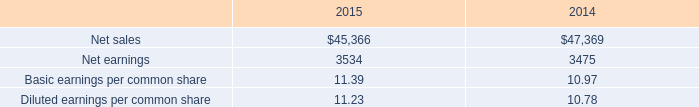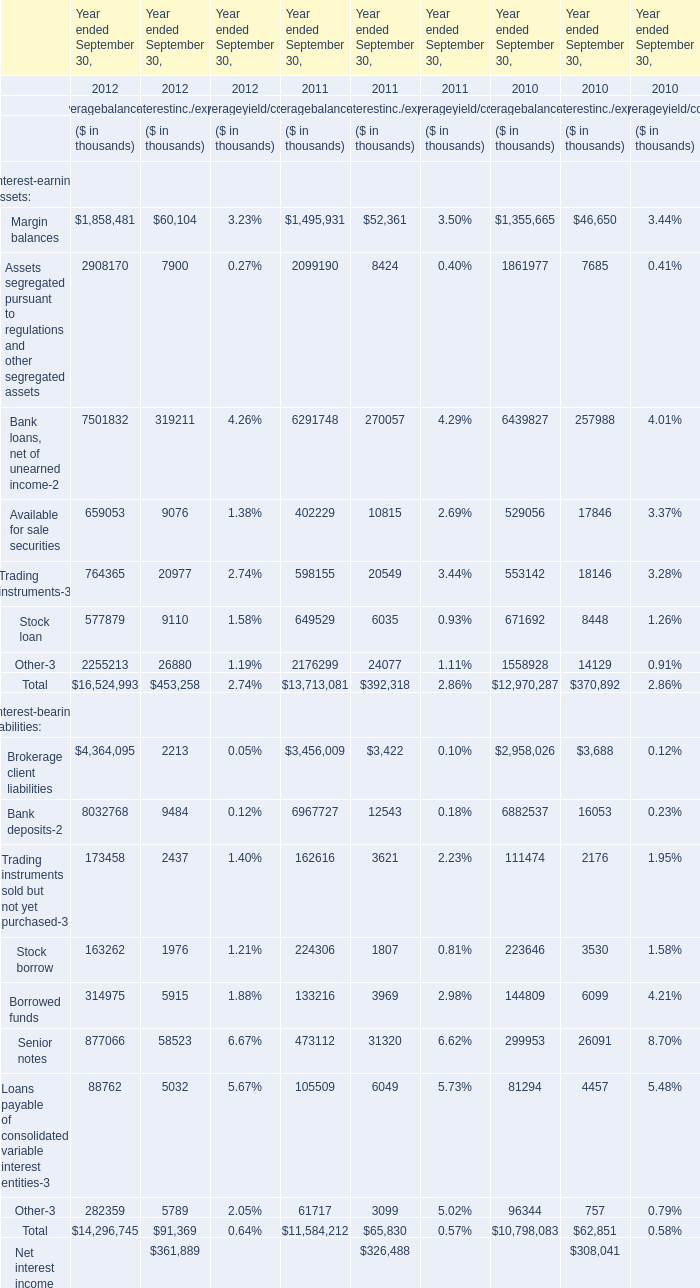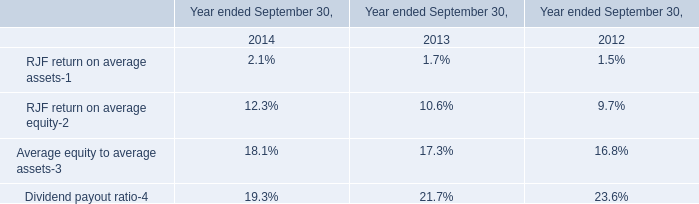what was the percentage change in net earnings from 2014 to 2015 for the pro forma financials? 
Computations: ((3534 - 3475) / 3475)
Answer: 0.01698. 